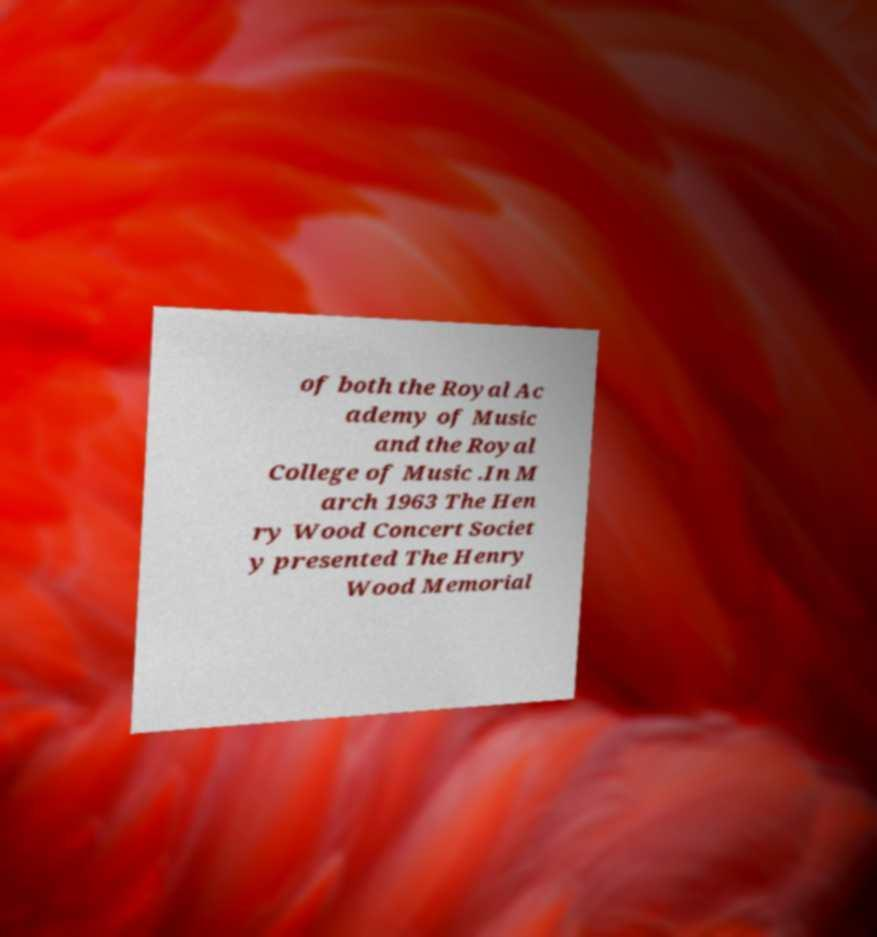Can you accurately transcribe the text from the provided image for me? of both the Royal Ac ademy of Music and the Royal College of Music .In M arch 1963 The Hen ry Wood Concert Societ y presented The Henry Wood Memorial 